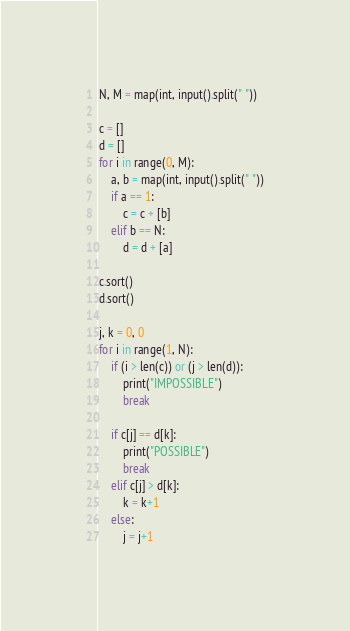<code> <loc_0><loc_0><loc_500><loc_500><_Python_>N, M = map(int, input().split(" "))

c = []
d = []
for i in range(0, M):
    a, b = map(int, input().split(" "))
    if a == 1:
        c = c + [b]
    elif b == N:
        d = d + [a]

c.sort()
d.sort()

j, k = 0, 0
for i in range(1, N):
    if (i > len(c)) or (j > len(d)):
        print("IMPOSSIBLE")
        break

    if c[j] == d[k]:
        print("POSSIBLE")
        break
    elif c[j] > d[k]:
        k = k+1
    else:
        j = j+1
</code> 